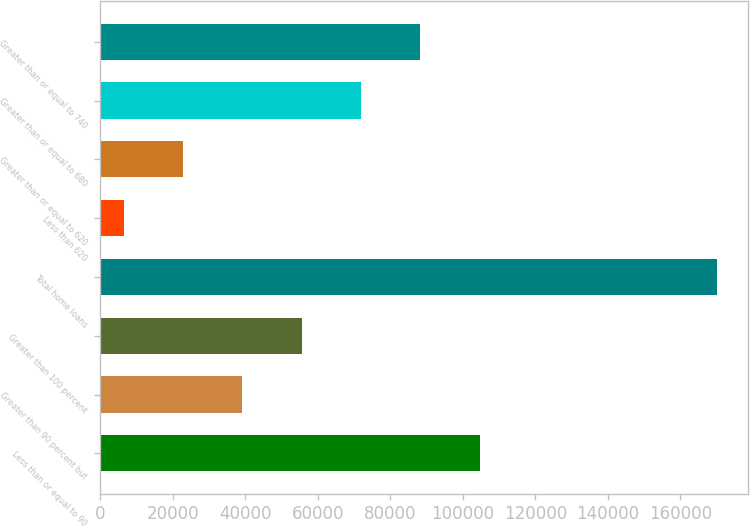Convert chart to OTSL. <chart><loc_0><loc_0><loc_500><loc_500><bar_chart><fcel>Less than or equal to 90<fcel>Greater than 90 percent but<fcel>Greater than 100 percent<fcel>Total home loans<fcel>Less than 620<fcel>Greater than or equal to 620<fcel>Greater than or equal to 680<fcel>Greater than or equal to 740<nl><fcel>104616<fcel>39116<fcel>55491<fcel>170116<fcel>6366<fcel>22741<fcel>71866<fcel>88241<nl></chart> 